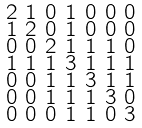<formula> <loc_0><loc_0><loc_500><loc_500>\begin{smallmatrix} 2 & 1 & 0 & 1 & 0 & 0 & 0 \\ 1 & 2 & 0 & 1 & 0 & 0 & 0 \\ 0 & 0 & 2 & 1 & 1 & 1 & 0 \\ 1 & 1 & 1 & 3 & 1 & 1 & 1 \\ 0 & 0 & 1 & 1 & 3 & 1 & 1 \\ 0 & 0 & 1 & 1 & 1 & 3 & 0 \\ 0 & 0 & 0 & 1 & 1 & 0 & 3 \end{smallmatrix}</formula> 